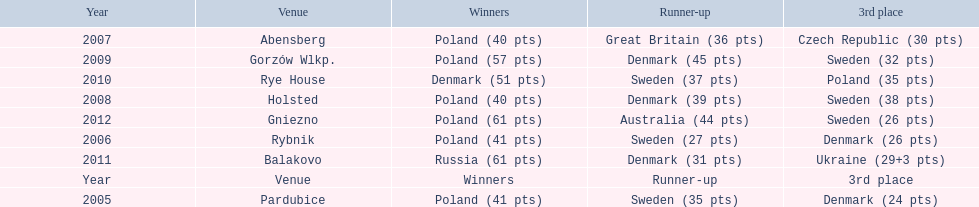Could you parse the entire table as a dict? {'header': ['Year', 'Venue', 'Winners', 'Runner-up', '3rd place'], 'rows': [['2007', 'Abensberg', 'Poland (40 pts)', 'Great Britain (36 pts)', 'Czech Republic (30 pts)'], ['2009', 'Gorzów Wlkp.', 'Poland (57 pts)', 'Denmark (45 pts)', 'Sweden (32 pts)'], ['2010', 'Rye House', 'Denmark (51 pts)', 'Sweden (37 pts)', 'Poland (35 pts)'], ['2008', 'Holsted', 'Poland (40 pts)', 'Denmark (39 pts)', 'Sweden (38 pts)'], ['2012', 'Gniezno', 'Poland (61 pts)', 'Australia (44 pts)', 'Sweden (26 pts)'], ['2006', 'Rybnik', 'Poland (41 pts)', 'Sweden (27 pts)', 'Denmark (26 pts)'], ['2011', 'Balakovo', 'Russia (61 pts)', 'Denmark (31 pts)', 'Ukraine (29+3 pts)'], ['Year', 'Venue', 'Winners', 'Runner-up', '3rd place'], ['2005', 'Pardubice', 'Poland (41 pts)', 'Sweden (35 pts)', 'Denmark (24 pts)']]} After their first place win in 2009, how did poland place the next year at the speedway junior world championship? 3rd place. 